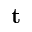<formula> <loc_0><loc_0><loc_500><loc_500>t</formula> 